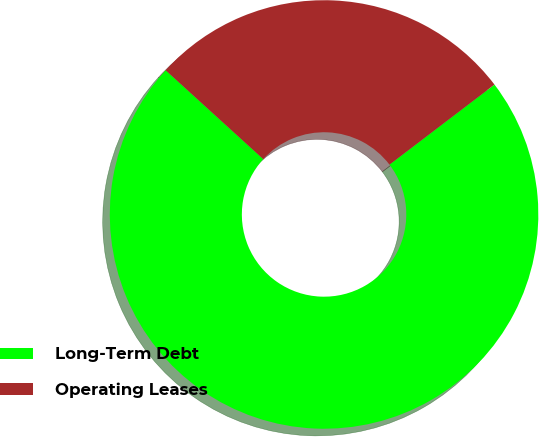<chart> <loc_0><loc_0><loc_500><loc_500><pie_chart><fcel>Long-Term Debt<fcel>Operating Leases<nl><fcel>72.12%<fcel>27.88%<nl></chart> 